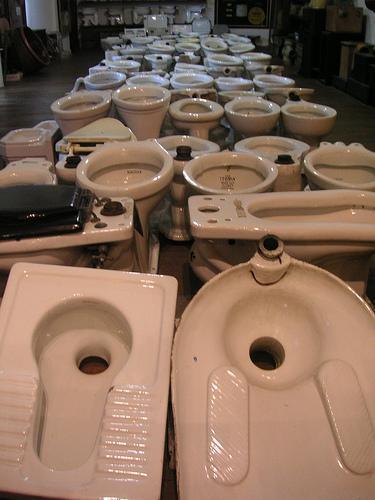How many black toilet seat covers are there?
Give a very brief answer. 1. How many toilets are in the third row from the bottom?
Give a very brief answer. 4. 